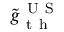<formula> <loc_0><loc_0><loc_500><loc_500>\tilde { g } _ { t h } ^ { U S }</formula> 